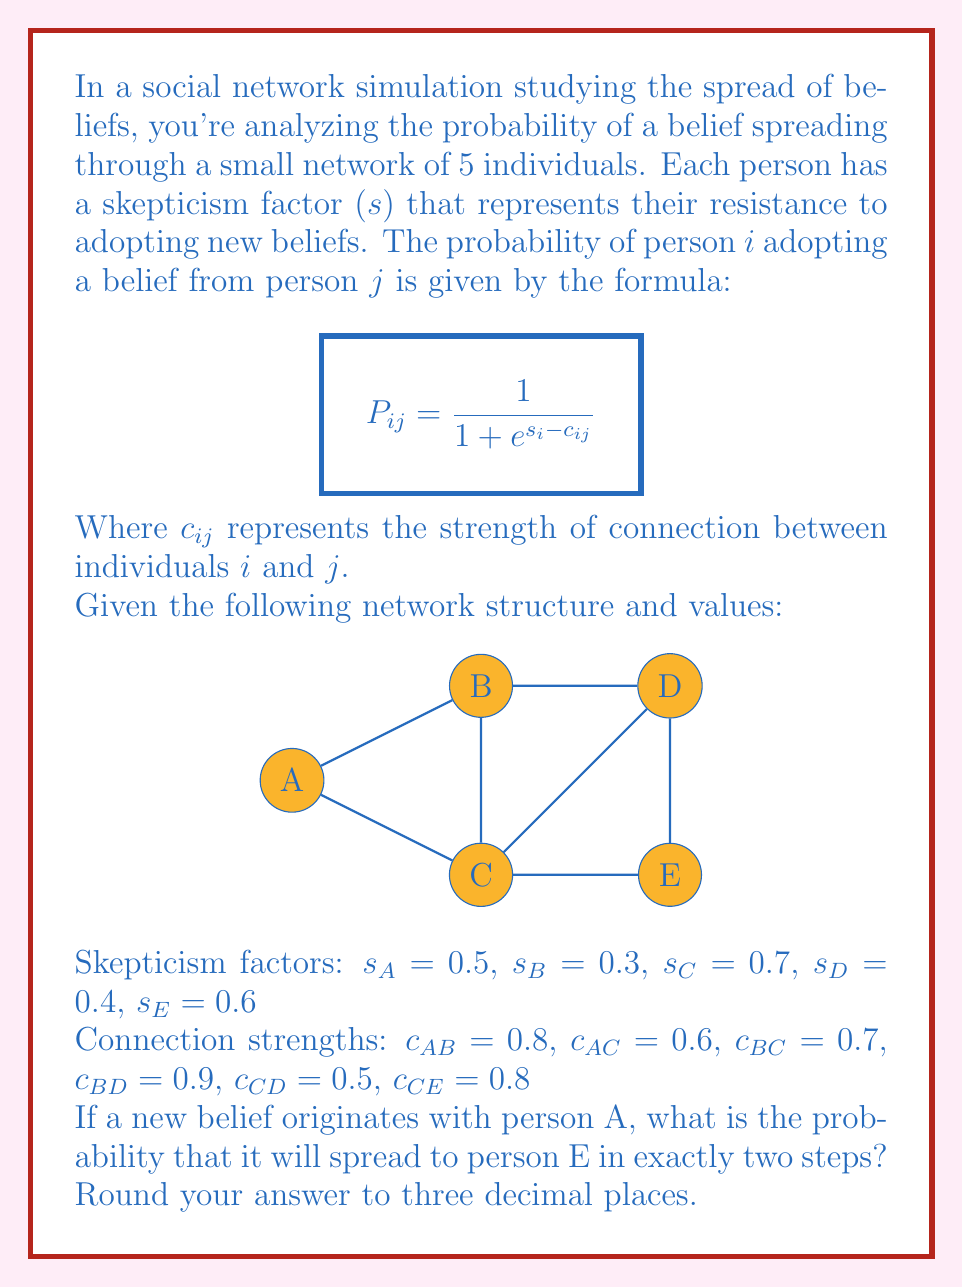Show me your answer to this math problem. To solve this problem, we need to consider all possible two-step paths from A to E and calculate their probabilities. The possible paths are:

1. A → B → D → E
2. A → C → E

Let's calculate each step:

1. For path A → B → D → E:

   a. P(A → B) = $\frac{1}{1 + e^{s_B - c_{AB}}} = \frac{1}{1 + e^{0.3 - 0.8}} = 0.6225$
   
   b. P(B → D) = $\frac{1}{1 + e^{s_D - c_{BD}}} = \frac{1}{1 + e^{0.4 - 0.9}} = 0.6225$
   
   c. P(D → E) = $\frac{1}{1 + e^{s_E - c_{CD}}} = \frac{1}{1 + e^{0.6 - 0.5}} = 0.4750$
   
   Probability of this path = 0.6225 × 0.6225 × 0.4750 = 0.1837

2. For path A → C → E:

   a. P(A → C) = $\frac{1}{1 + e^{s_C - c_{AC}}} = \frac{1}{1 + e^{0.7 - 0.6}} = 0.4750$
   
   b. P(C → E) = $\frac{1}{1 + e^{s_E - c_{CE}}} = \frac{1}{1 + e^{0.6 - 0.8}} = 0.5498$
   
   Probability of this path = 0.4750 × 0.5498 = 0.2612

The total probability is the sum of these two path probabilities:

0.1837 + 0.2612 = 0.4449

Rounding to three decimal places: 0.445
Answer: 0.445 